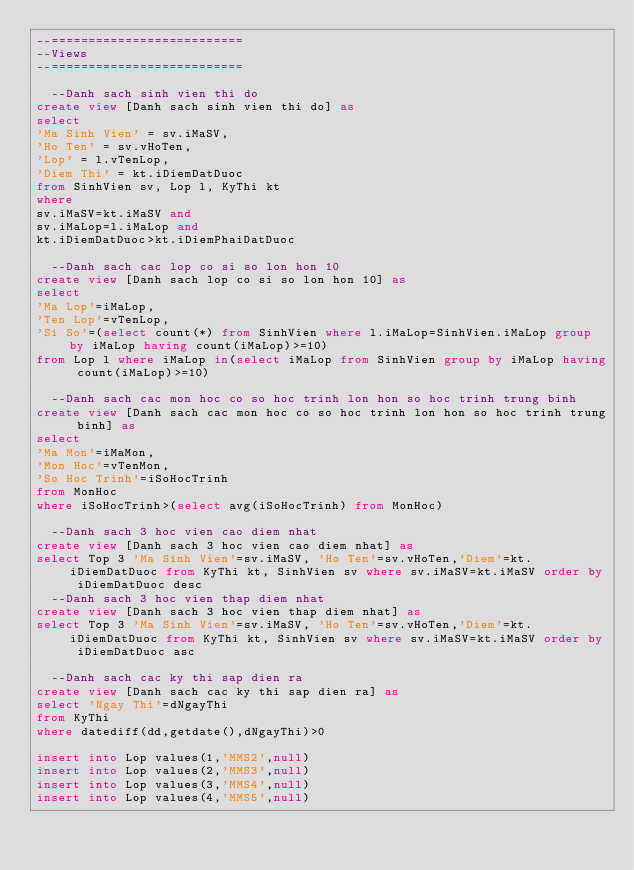Convert code to text. <code><loc_0><loc_0><loc_500><loc_500><_SQL_>--==========================
--Views
--==========================

  --Danh sach sinh vien thi do
create view [Danh sach sinh vien thi do] as
select
'Ma Sinh Vien' = sv.iMaSV, 
'Ho Ten' = sv.vHoTen, 
'Lop' = l.vTenLop, 
'Diem Thi' = kt.iDiemDatDuoc
from SinhVien sv, Lop l, KyThi kt
where 
sv.iMaSV=kt.iMaSV and 
sv.iMaLop=l.iMaLop and
kt.iDiemDatDuoc>kt.iDiemPhaiDatDuoc

  --Danh sach cac lop co si so lon hon 10
create view [Danh sach lop co si so lon hon 10] as
select
'Ma Lop'=iMaLop,
'Ten Lop'=vTenLop,
'Si So'=(select count(*) from SinhVien where l.iMaLop=SinhVien.iMaLop group by iMaLop having count(iMaLop)>=10)
from Lop l where iMaLop in(select iMaLop from SinhVien group by iMaLop having count(iMaLop)>=10)

  --Danh sach cac mon hoc co so hoc trinh lon hon so hoc trinh trung binh
create view [Danh sach cac mon hoc co so hoc trinh lon hon so hoc trinh trung binh] as
select
'Ma Mon'=iMaMon,
'Mon Hoc'=vTenMon,
'So Hoc Trinh'=iSoHocTrinh
from MonHoc
where iSoHocTrinh>(select avg(iSoHocTrinh) from MonHoc)

  --Danh sach 3 hoc vien cao diem nhat
create view [Danh sach 3 hoc vien cao diem nhat] as
select Top 3 'Ma Sinh Vien'=sv.iMaSV, 'Ho Ten'=sv.vHoTen,'Diem'=kt.iDiemDatDuoc from KyThi kt, SinhVien sv where sv.iMaSV=kt.iMaSV order by iDiemDatDuoc desc
  --Danh sach 3 hoc vien thap diem nhat
create view [Danh sach 3 hoc vien thap diem nhat] as
select Top 3 'Ma Sinh Vien'=sv.iMaSV, 'Ho Ten'=sv.vHoTen,'Diem'=kt.iDiemDatDuoc from KyThi kt, SinhVien sv where sv.iMaSV=kt.iMaSV order by iDiemDatDuoc asc

  --Danh sach cac ky thi sap dien ra
create view [Danh sach cac ky thi sap dien ra] as
select 'Ngay Thi'=dNgayThi
from KyThi
where datediff(dd,getdate(),dNgayThi)>0

insert into Lop values(1,'MMS2',null)
insert into Lop values(2,'MMS3',null)
insert into Lop values(3,'MMS4',null)
insert into Lop values(4,'MMS5',null)</code> 